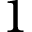<formula> <loc_0><loc_0><loc_500><loc_500>1</formula> 